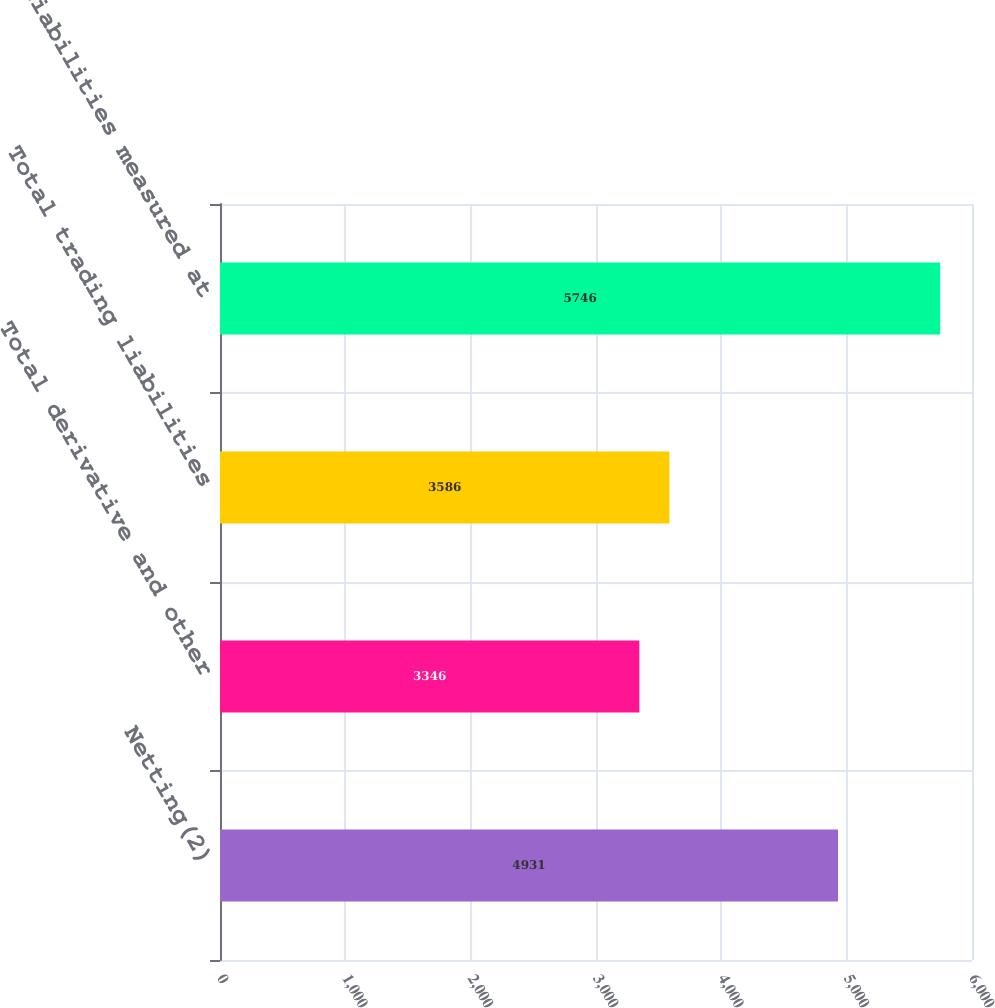Convert chart. <chart><loc_0><loc_0><loc_500><loc_500><bar_chart><fcel>Netting(2)<fcel>Total derivative and other<fcel>Total trading liabilities<fcel>Total liabilities measured at<nl><fcel>4931<fcel>3346<fcel>3586<fcel>5746<nl></chart> 